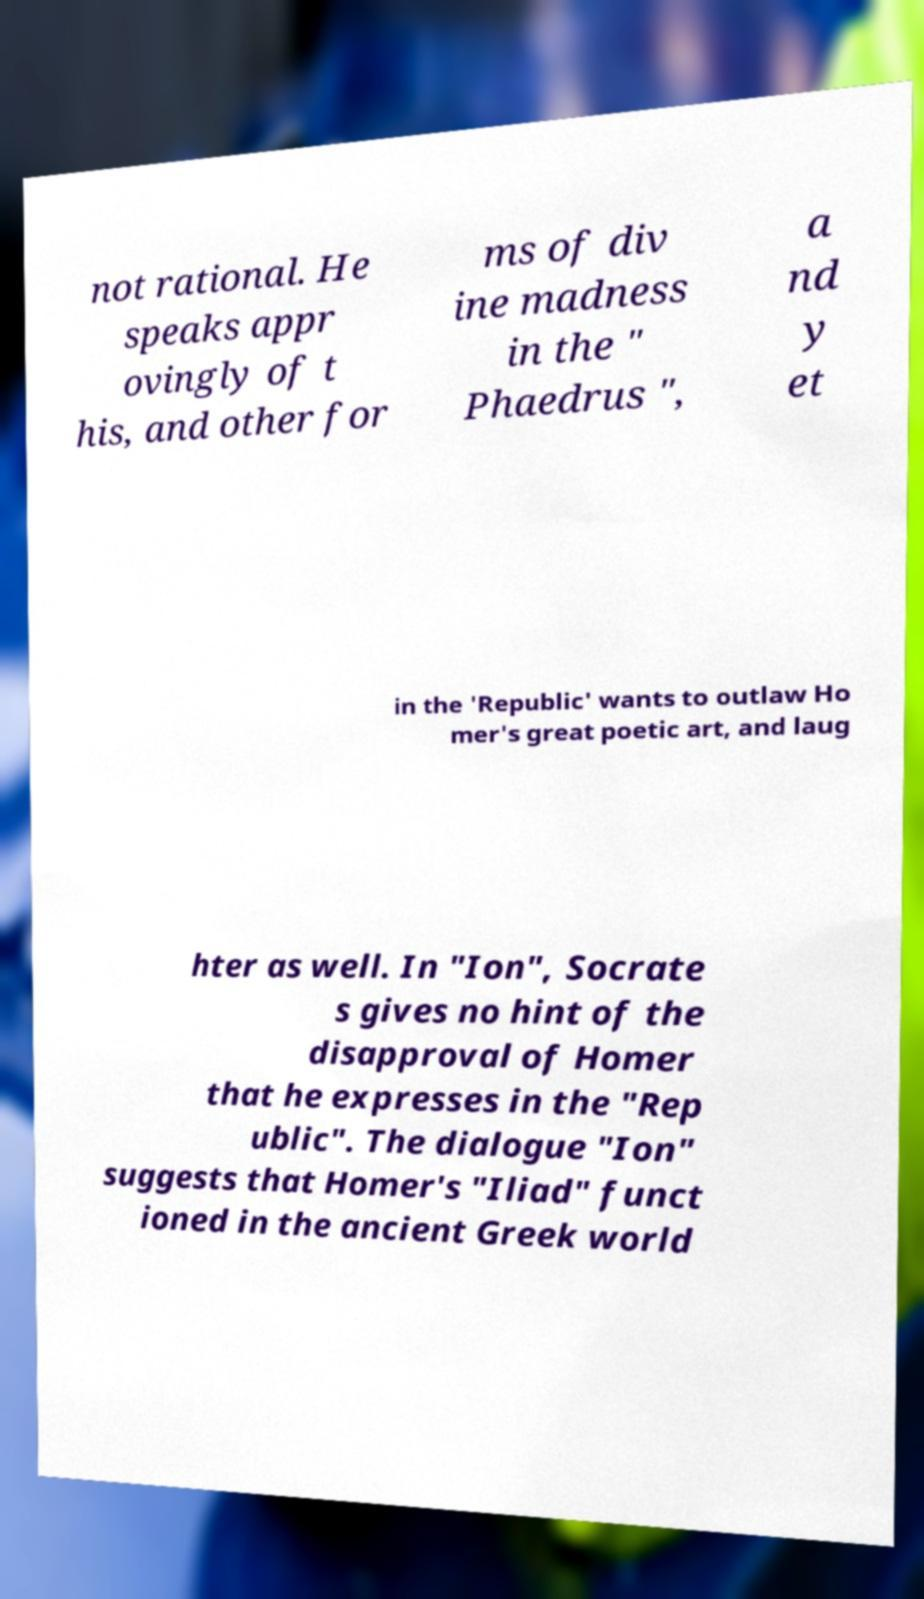Could you extract and type out the text from this image? not rational. He speaks appr ovingly of t his, and other for ms of div ine madness in the " Phaedrus ", a nd y et in the 'Republic' wants to outlaw Ho mer's great poetic art, and laug hter as well. In "Ion", Socrate s gives no hint of the disapproval of Homer that he expresses in the "Rep ublic". The dialogue "Ion" suggests that Homer's "Iliad" funct ioned in the ancient Greek world 